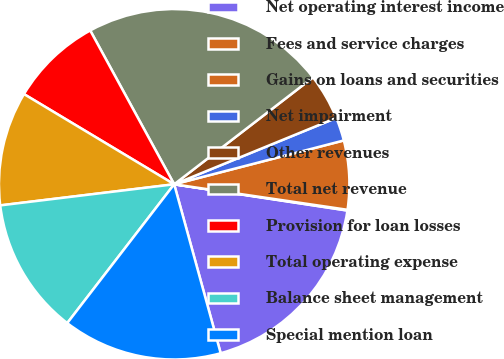<chart> <loc_0><loc_0><loc_500><loc_500><pie_chart><fcel>Net operating interest income<fcel>Fees and service charges<fcel>Gains on loans and securities<fcel>Net impairment<fcel>Other revenues<fcel>Total net revenue<fcel>Provision for loan losses<fcel>Total operating expense<fcel>Balance sheet management<fcel>Special mention loan<nl><fcel>18.33%<fcel>0.07%<fcel>6.35%<fcel>2.16%<fcel>4.26%<fcel>22.51%<fcel>8.44%<fcel>10.53%<fcel>12.63%<fcel>14.72%<nl></chart> 